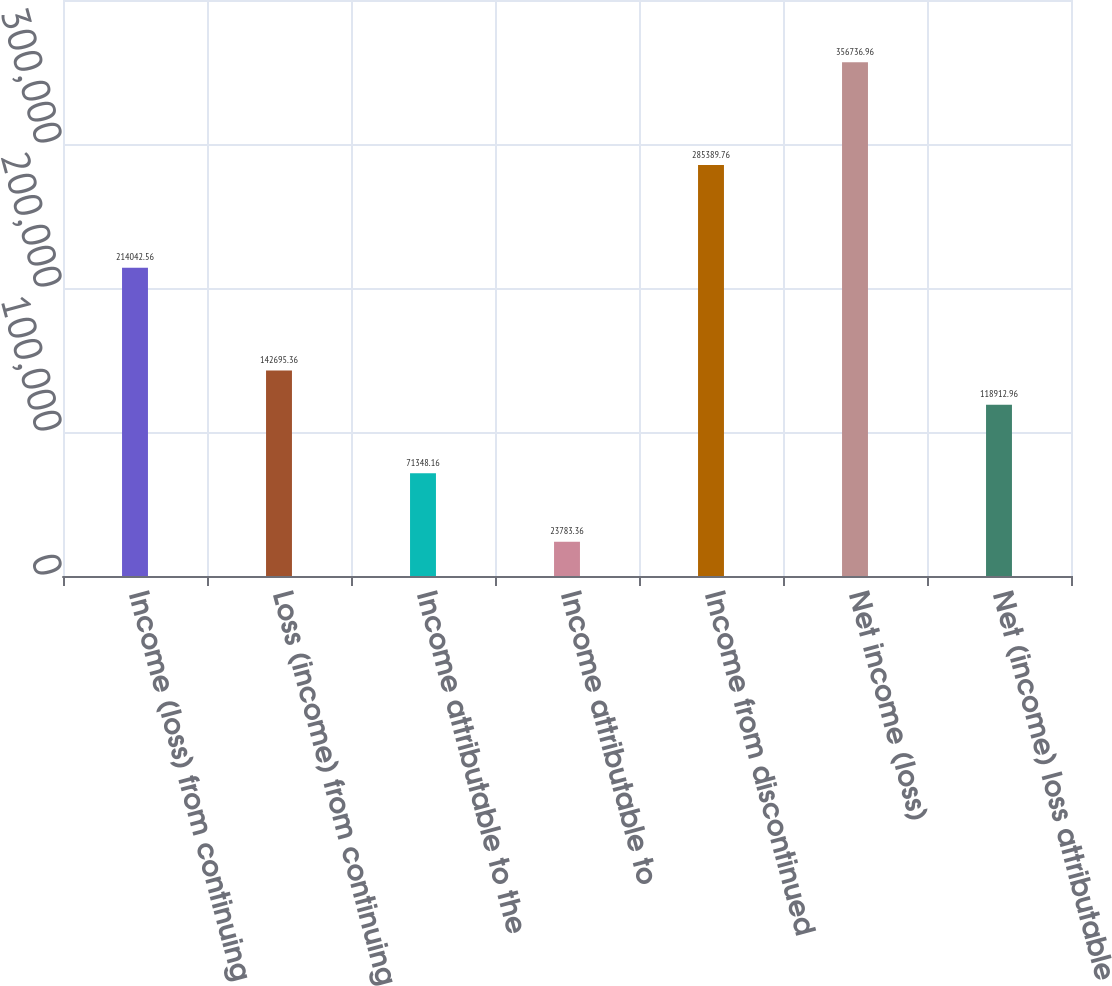<chart> <loc_0><loc_0><loc_500><loc_500><bar_chart><fcel>Income (loss) from continuing<fcel>Loss (income) from continuing<fcel>Income attributable to the<fcel>Income attributable to<fcel>Income from discontinued<fcel>Net income (loss)<fcel>Net (income) loss attributable<nl><fcel>214043<fcel>142695<fcel>71348.2<fcel>23783.4<fcel>285390<fcel>356737<fcel>118913<nl></chart> 